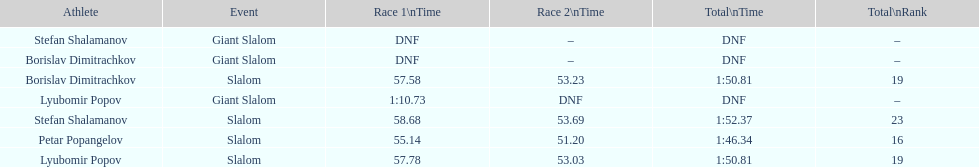Which athletes had consecutive times under 58 for both races? Lyubomir Popov, Borislav Dimitrachkov, Petar Popangelov. 